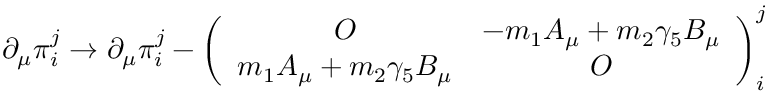Convert formula to latex. <formula><loc_0><loc_0><loc_500><loc_500>\partial _ { \mu } \pi _ { i } ^ { j } \to \partial _ { \mu } \pi _ { i } ^ { j } - \left ( \begin{array} { c c } { O } & { { - m _ { 1 } A _ { \mu } + m _ { 2 } \gamma _ { 5 } B _ { \mu } } } \\ { { m _ { 1 } A _ { \mu } + m _ { 2 } \gamma _ { 5 } B _ { \mu } } } & { O } \end{array} \right ) _ { i } ^ { j }</formula> 